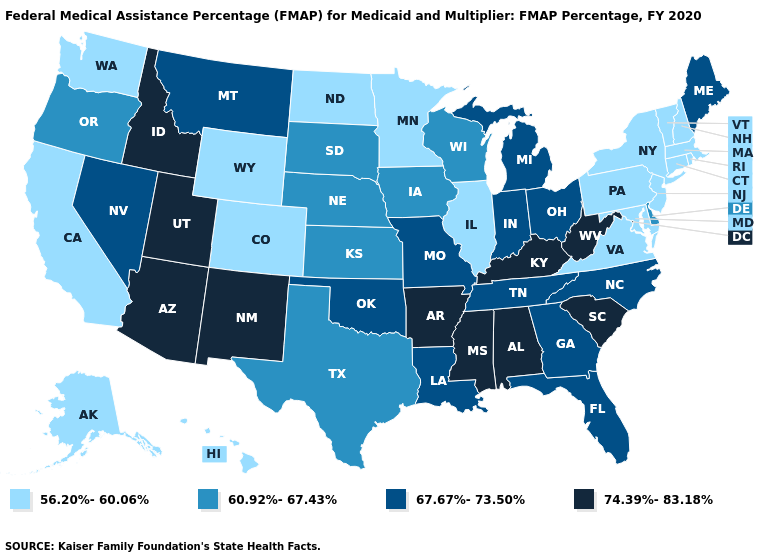Does the first symbol in the legend represent the smallest category?
Short answer required. Yes. What is the lowest value in states that border New York?
Concise answer only. 56.20%-60.06%. Among the states that border North Dakota , does Minnesota have the lowest value?
Write a very short answer. Yes. Name the states that have a value in the range 74.39%-83.18%?
Be succinct. Alabama, Arizona, Arkansas, Idaho, Kentucky, Mississippi, New Mexico, South Carolina, Utah, West Virginia. Among the states that border Oklahoma , which have the lowest value?
Concise answer only. Colorado. Is the legend a continuous bar?
Keep it brief. No. Does New Mexico have the highest value in the West?
Keep it brief. Yes. Among the states that border New Hampshire , which have the highest value?
Answer briefly. Maine. How many symbols are there in the legend?
Answer briefly. 4. Does the map have missing data?
Be succinct. No. What is the value of Alabama?
Be succinct. 74.39%-83.18%. What is the value of Nebraska?
Keep it brief. 60.92%-67.43%. Does Iowa have the highest value in the MidWest?
Concise answer only. No. What is the value of New Jersey?
Give a very brief answer. 56.20%-60.06%. Among the states that border Maine , which have the lowest value?
Answer briefly. New Hampshire. 